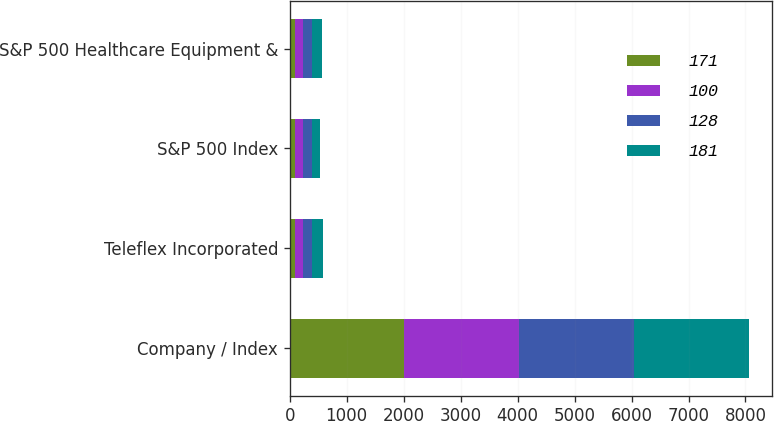Convert chart to OTSL. <chart><loc_0><loc_0><loc_500><loc_500><stacked_bar_chart><ecel><fcel>Company / Index<fcel>Teleflex Incorporated<fcel>S&P 500 Index<fcel>S&P 500 Healthcare Equipment &<nl><fcel>171<fcel>2012<fcel>100<fcel>100<fcel>100<nl><fcel>100<fcel>2013<fcel>134<fcel>132<fcel>128<nl><fcel>128<fcel>2014<fcel>166<fcel>151<fcel>161<nl><fcel>181<fcel>2015<fcel>192<fcel>153<fcel>171<nl></chart> 